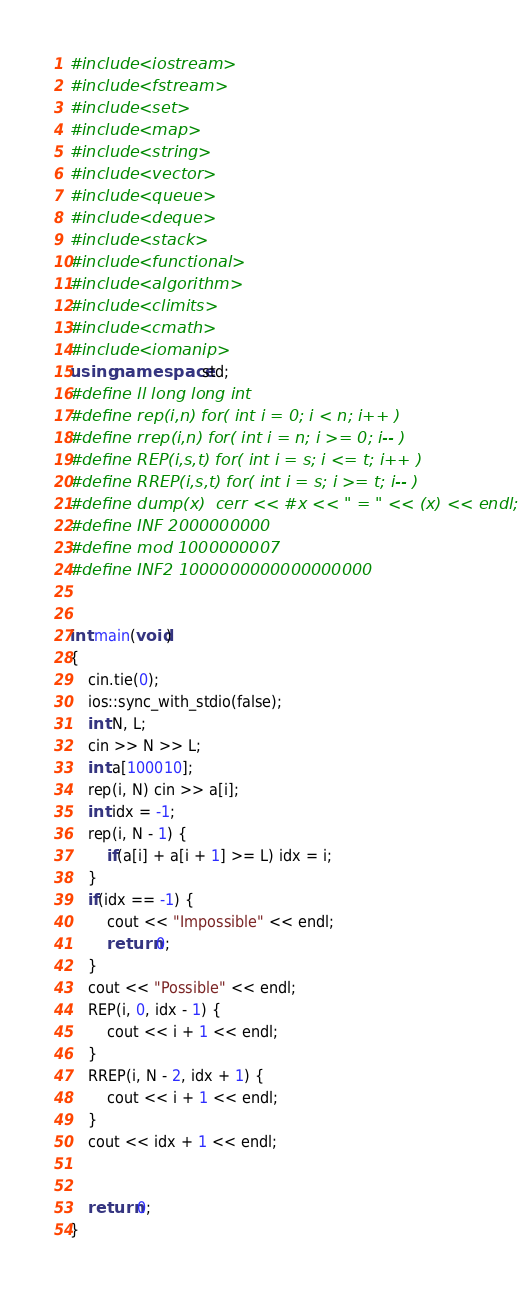Convert code to text. <code><loc_0><loc_0><loc_500><loc_500><_C++_>#include <iostream>
#include <fstream>
#include <set>
#include <map>
#include <string>
#include <vector>
#include <queue>
#include <deque>
#include <stack>
#include <functional>
#include <algorithm>
#include <climits>
#include <cmath>
#include <iomanip>
using namespace std;
#define ll long long int
#define rep(i,n) for( int i = 0; i < n; i++ )
#define rrep(i,n) for( int i = n; i >= 0; i-- )
#define REP(i,s,t) for( int i = s; i <= t; i++ )
#define RREP(i,s,t) for( int i = s; i >= t; i-- )
#define dump(x)  cerr << #x << " = " << (x) << endl;
#define INF 2000000000
#define mod 1000000007
#define INF2 1000000000000000000


int main(void)
{
    cin.tie(0);
    ios::sync_with_stdio(false);
    int N, L;
    cin >> N >> L;
    int a[100010];
    rep(i, N) cin >> a[i];
    int idx = -1;
    rep(i, N - 1) {
        if(a[i] + a[i + 1] >= L) idx = i;
    }
    if(idx == -1) {
        cout << "Impossible" << endl;
        return 0;
    }
    cout << "Possible" << endl;
    REP(i, 0, idx - 1) {
        cout << i + 1 << endl;
    }
    RREP(i, N - 2, idx + 1) {
        cout << i + 1 << endl;
    }
    cout << idx + 1 << endl;


    return 0;
}
</code> 